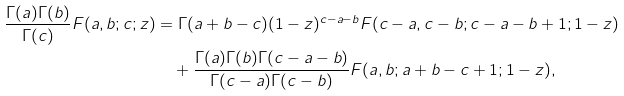Convert formula to latex. <formula><loc_0><loc_0><loc_500><loc_500>\frac { \Gamma ( a ) \Gamma ( b ) } { \Gamma ( c ) } F ( a , b ; c ; z ) & = \Gamma ( a + b - c ) ( 1 - z ) ^ { c - a - b } F ( c - a , c - b ; c - a - b + 1 ; 1 - z ) \\ & \quad + \frac { \Gamma ( a ) \Gamma ( b ) \Gamma ( c - a - b ) } { \Gamma ( c - a ) \Gamma ( c - b ) } F ( a , b ; a + b - c + 1 ; 1 - z ) ,</formula> 